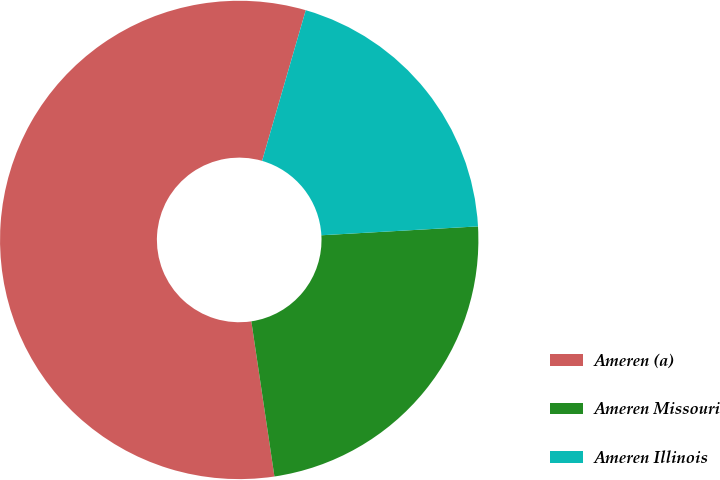<chart> <loc_0><loc_0><loc_500><loc_500><pie_chart><fcel>Ameren (a)<fcel>Ameren Missouri<fcel>Ameren Illinois<nl><fcel>56.84%<fcel>23.55%<fcel>19.61%<nl></chart> 